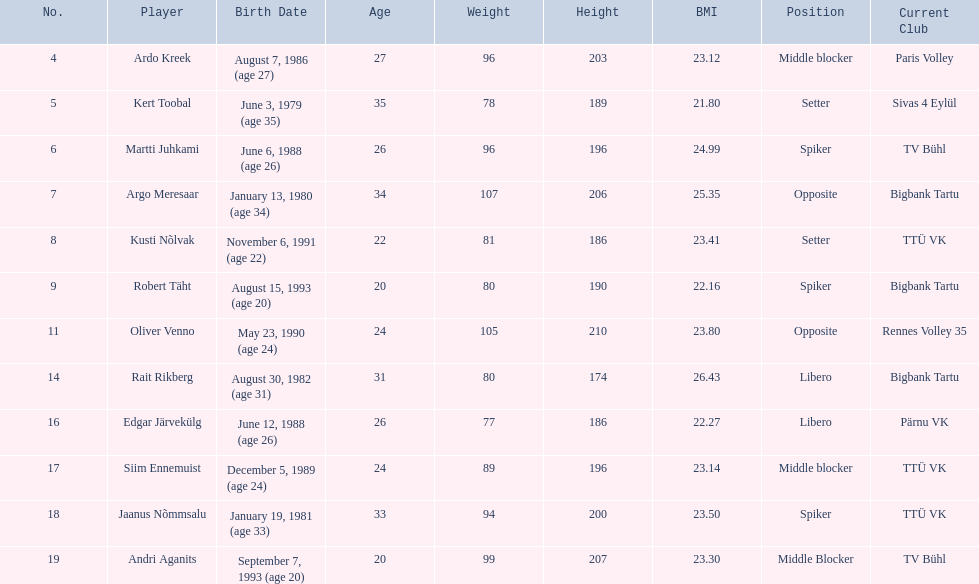What are the heights in cm of the men on the team? 203, 189, 196, 206, 186, 190, 210, 174, 186, 196, 200, 207. What is the tallest height of a team member? 210. Which player stands at 210? Oliver Venno. 